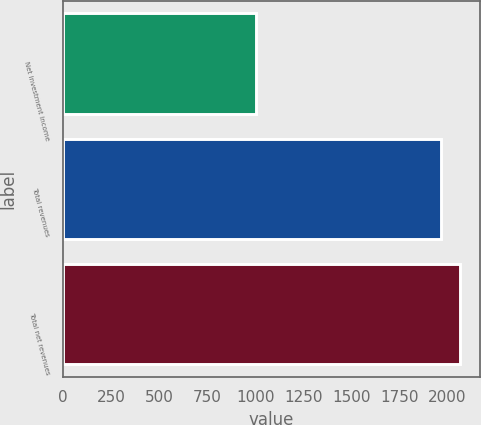Convert chart. <chart><loc_0><loc_0><loc_500><loc_500><bar_chart><fcel>Net investment income<fcel>Total revenues<fcel>Total net revenues<nl><fcel>1002<fcel>1968<fcel>2064.6<nl></chart> 